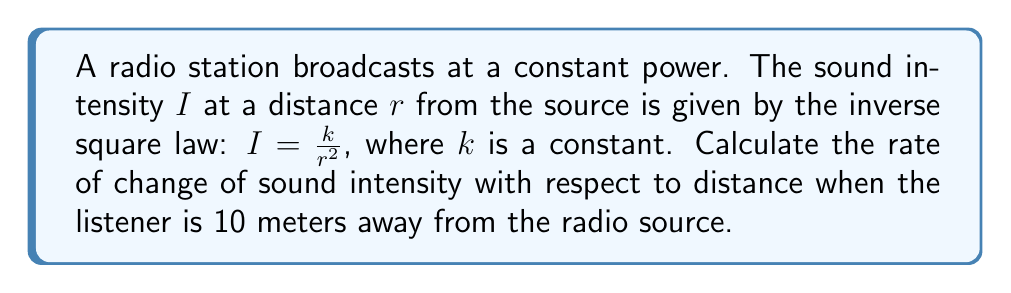Show me your answer to this math problem. To solve this problem, we need to find the derivative of the sound intensity function with respect to distance. Let's approach this step-by-step:

1) The given function for sound intensity is:

   $$I = \frac{k}{r^2}$$

2) We need to find $\frac{dI}{dr}$, which represents the rate of change of intensity with respect to distance.

3) Using the power rule of differentiation:

   $$\frac{dI}{dr} = k \cdot \frac{d}{dr}(r^{-2})$$
   $$\frac{dI}{dr} = k \cdot (-2r^{-3})$$
   $$\frac{dI}{dr} = -\frac{2k}{r^3}$$

4) Now, we need to evaluate this at $r = 10$ meters:

   $$\left.\frac{dI}{dr}\right|_{r=10} = -\frac{2k}{10^3} = -\frac{k}{500}$$

5) The negative sign indicates that the intensity decreases as distance increases.

6) Note that we can't give a numerical answer because $k$ is unknown. However, we can express the answer in terms of $k$.
Answer: The rate of change of sound intensity with respect to distance when the listener is 10 meters away from the radio source is $-\frac{k}{500}$ watts per square meter per meter, where $k$ is the constant in the original intensity equation. 